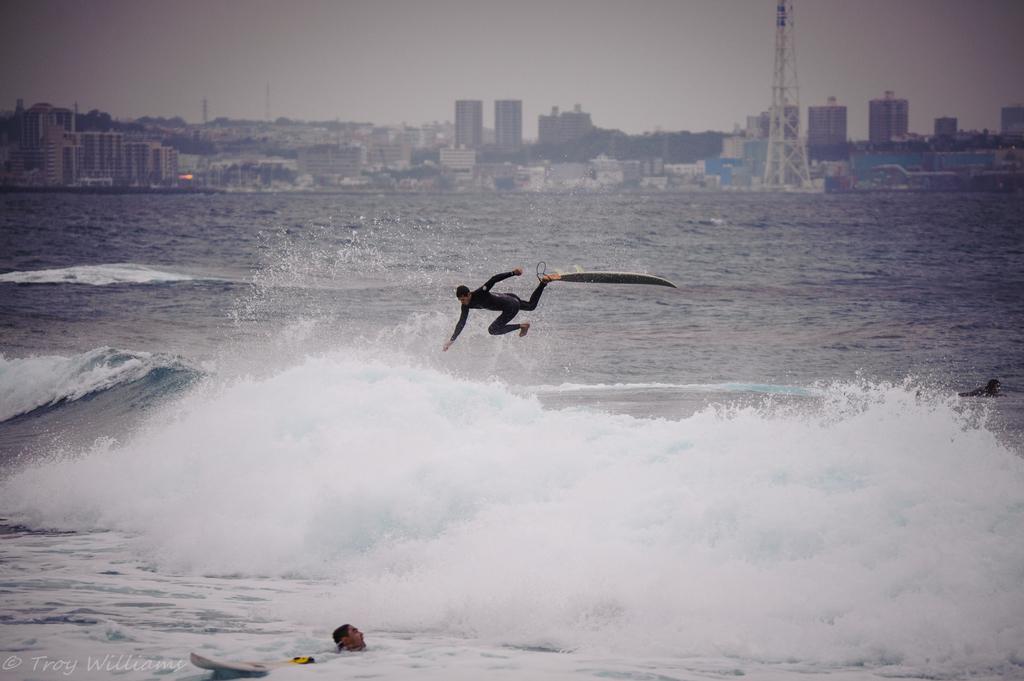Describe this image in one or two sentences. In this image center there is person in the water. In the background there is a person para surfing on water and there is an ocean and there are buildings. There is a tower. 